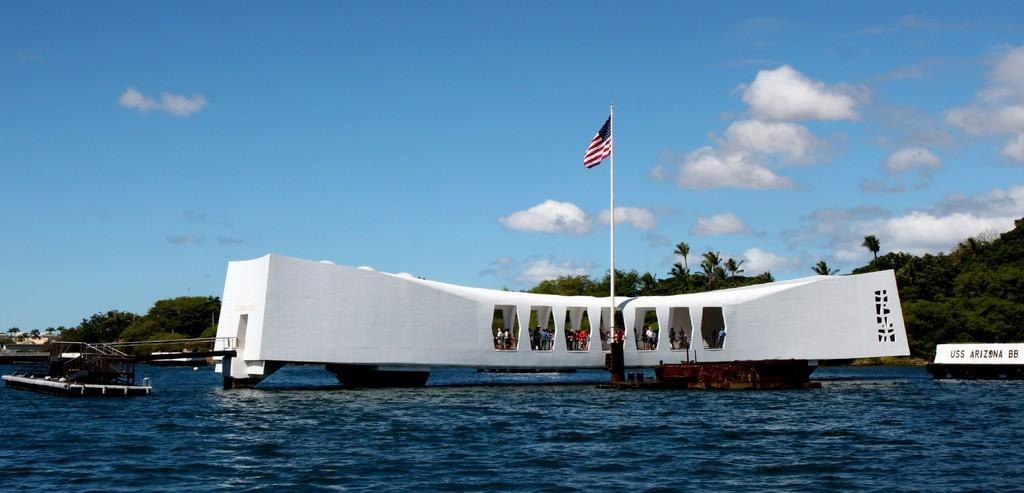<image>
Give a short and clear explanation of the subsequent image. A picture of a structure on the water that says the USS Arizona. 